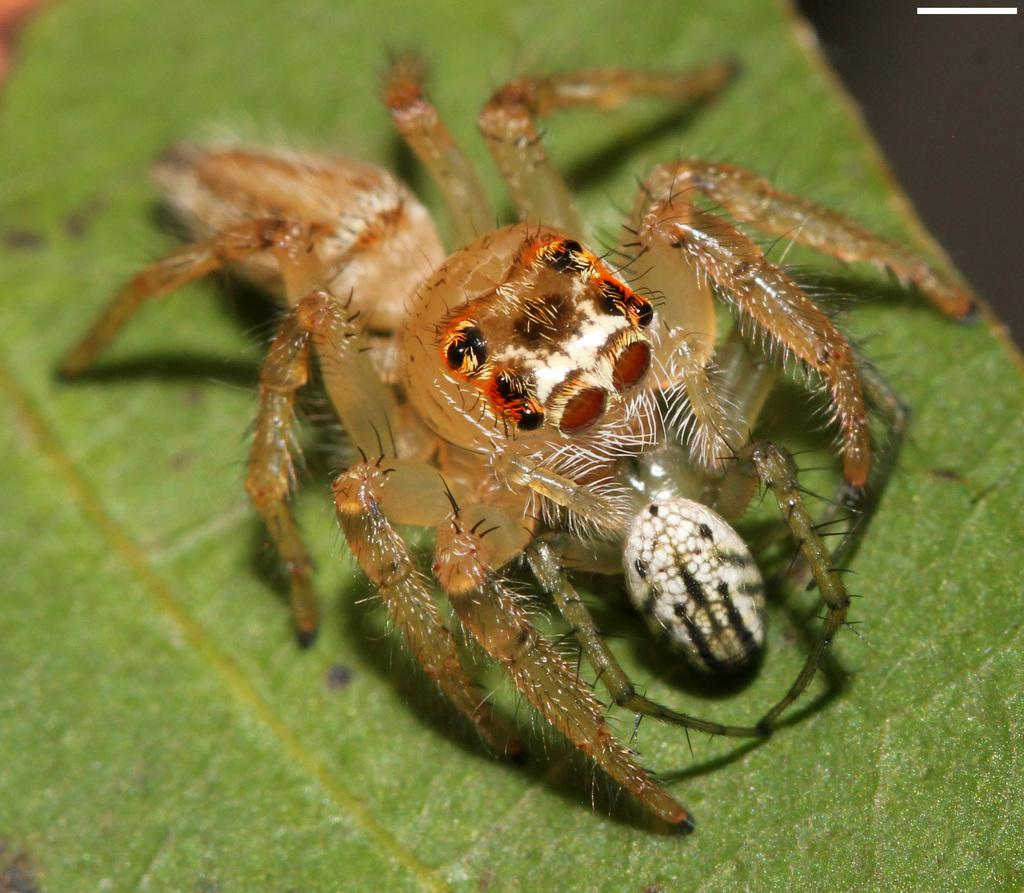What is the main subject of the image? There is a spider in the image. Where is the spider located? The spider is on a green leaf. What can be seen in the background of the image? There is a blurred view at the top of the image. How many girls are visible in the image? There are no girls present in the image; it features a spider on a green leaf. What type of light source is illuminating the spider in the image? There is no specific light source mentioned or visible in the image; it simply shows a spider on a green leaf with a blurred background. 